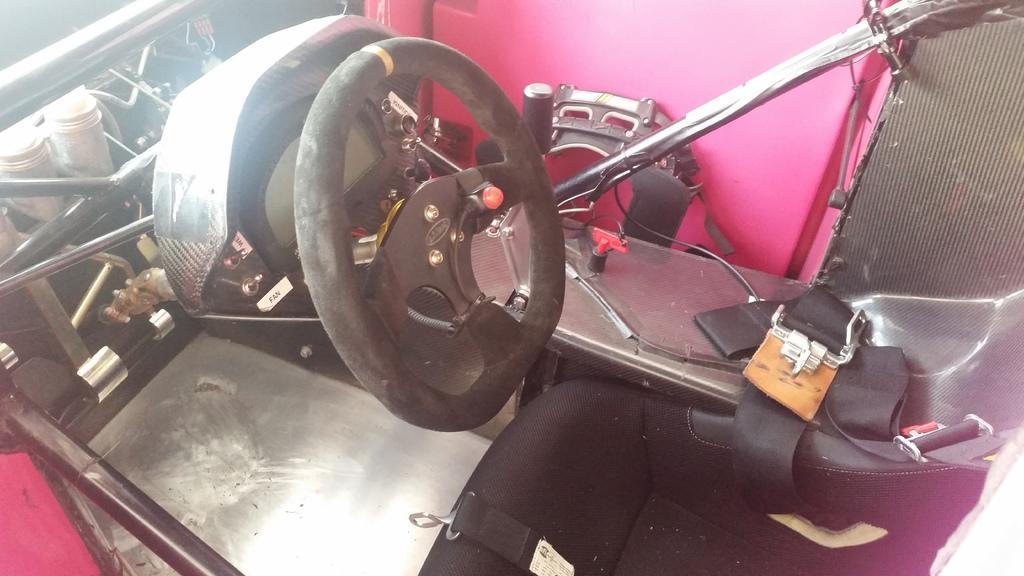In one or two sentences, can you explain what this image depicts? This picture describes about inside view of the vehicle, in this we can find a steering and metal rods. 